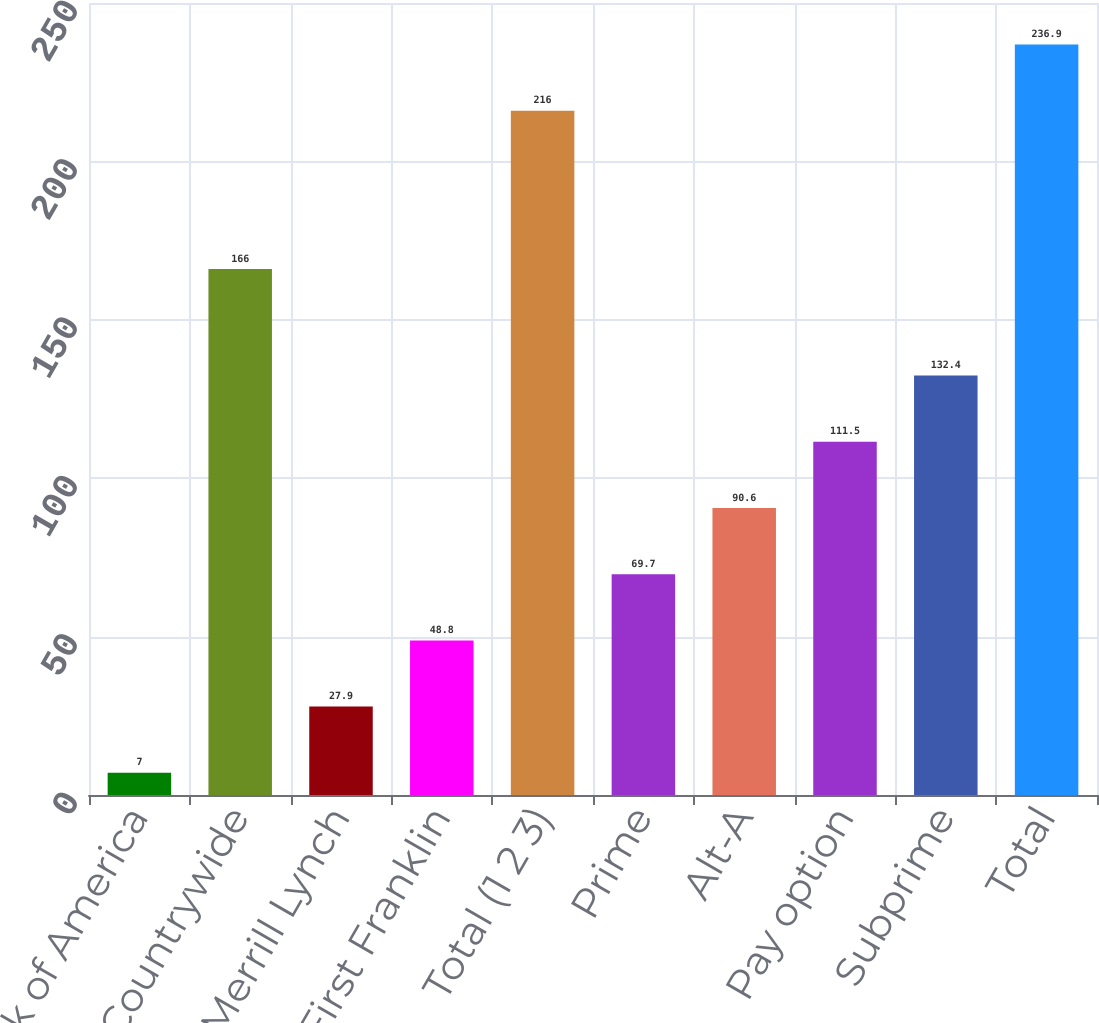Convert chart. <chart><loc_0><loc_0><loc_500><loc_500><bar_chart><fcel>Bank of America<fcel>Countrywide<fcel>Merrill Lynch<fcel>First Franklin<fcel>Total (1 2 3)<fcel>Prime<fcel>Alt-A<fcel>Pay option<fcel>Subprime<fcel>Total<nl><fcel>7<fcel>166<fcel>27.9<fcel>48.8<fcel>216<fcel>69.7<fcel>90.6<fcel>111.5<fcel>132.4<fcel>236.9<nl></chart> 